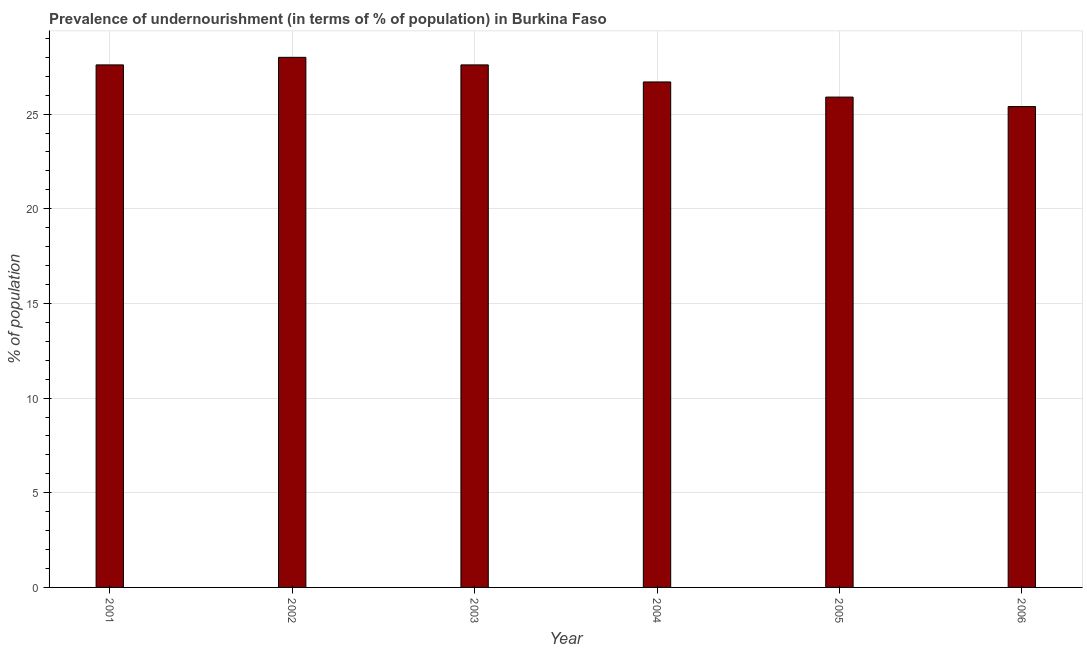What is the title of the graph?
Make the answer very short. Prevalence of undernourishment (in terms of % of population) in Burkina Faso. What is the label or title of the X-axis?
Offer a terse response. Year. What is the label or title of the Y-axis?
Give a very brief answer. % of population. What is the percentage of undernourished population in 2003?
Your answer should be very brief. 27.6. Across all years, what is the minimum percentage of undernourished population?
Your answer should be very brief. 25.4. In which year was the percentage of undernourished population minimum?
Offer a terse response. 2006. What is the sum of the percentage of undernourished population?
Your answer should be compact. 161.2. What is the average percentage of undernourished population per year?
Provide a succinct answer. 26.87. What is the median percentage of undernourished population?
Keep it short and to the point. 27.15. In how many years, is the percentage of undernourished population greater than 3 %?
Your answer should be compact. 6. What is the ratio of the percentage of undernourished population in 2004 to that in 2005?
Offer a very short reply. 1.03. Is the percentage of undernourished population in 2002 less than that in 2005?
Offer a terse response. No. Is the difference between the percentage of undernourished population in 2001 and 2005 greater than the difference between any two years?
Provide a succinct answer. No. How many bars are there?
Give a very brief answer. 6. How many years are there in the graph?
Your response must be concise. 6. What is the difference between two consecutive major ticks on the Y-axis?
Your response must be concise. 5. Are the values on the major ticks of Y-axis written in scientific E-notation?
Provide a short and direct response. No. What is the % of population in 2001?
Your answer should be compact. 27.6. What is the % of population of 2003?
Your response must be concise. 27.6. What is the % of population of 2004?
Offer a very short reply. 26.7. What is the % of population of 2005?
Your response must be concise. 25.9. What is the % of population of 2006?
Ensure brevity in your answer.  25.4. What is the difference between the % of population in 2001 and 2004?
Offer a terse response. 0.9. What is the difference between the % of population in 2001 and 2005?
Provide a short and direct response. 1.7. What is the difference between the % of population in 2002 and 2006?
Provide a short and direct response. 2.6. What is the difference between the % of population in 2003 and 2005?
Your answer should be very brief. 1.7. What is the difference between the % of population in 2003 and 2006?
Offer a terse response. 2.2. What is the difference between the % of population in 2004 and 2006?
Keep it short and to the point. 1.3. What is the ratio of the % of population in 2001 to that in 2004?
Your answer should be very brief. 1.03. What is the ratio of the % of population in 2001 to that in 2005?
Give a very brief answer. 1.07. What is the ratio of the % of population in 2001 to that in 2006?
Offer a terse response. 1.09. What is the ratio of the % of population in 2002 to that in 2004?
Offer a terse response. 1.05. What is the ratio of the % of population in 2002 to that in 2005?
Give a very brief answer. 1.08. What is the ratio of the % of population in 2002 to that in 2006?
Provide a short and direct response. 1.1. What is the ratio of the % of population in 2003 to that in 2004?
Ensure brevity in your answer.  1.03. What is the ratio of the % of population in 2003 to that in 2005?
Give a very brief answer. 1.07. What is the ratio of the % of population in 2003 to that in 2006?
Make the answer very short. 1.09. What is the ratio of the % of population in 2004 to that in 2005?
Keep it short and to the point. 1.03. What is the ratio of the % of population in 2004 to that in 2006?
Ensure brevity in your answer.  1.05. 